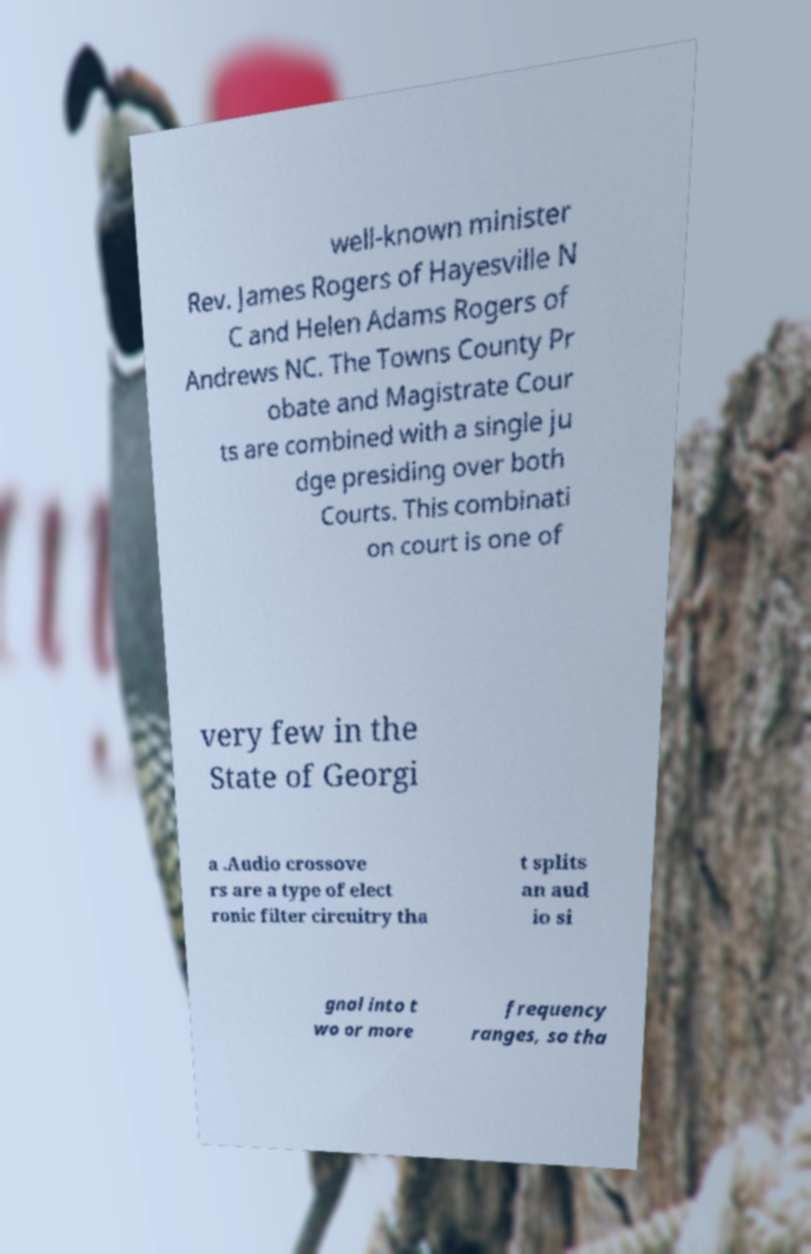Please identify and transcribe the text found in this image. well-known minister Rev. James Rogers of Hayesville N C and Helen Adams Rogers of Andrews NC. The Towns County Pr obate and Magistrate Cour ts are combined with a single ju dge presiding over both Courts. This combinati on court is one of very few in the State of Georgi a .Audio crossove rs are a type of elect ronic filter circuitry tha t splits an aud io si gnal into t wo or more frequency ranges, so tha 